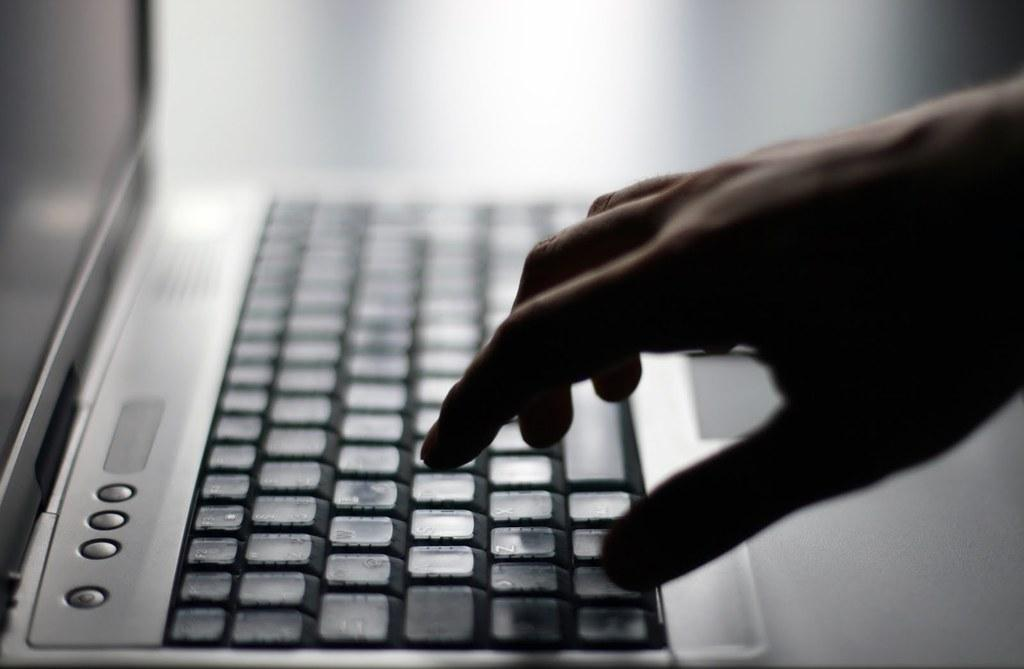What electronic device is present in the image? There is a laptop in the image. What colors can be seen on the laptop? The laptop is grey and black in color. Whose hand is visible in the image? A person's hand is visible in the image. How would you describe the background of the image? The background of the image is blurry. How many circles can be seen on the laptop's screen in the image? There are no circles visible on the laptop's screen in the image. 